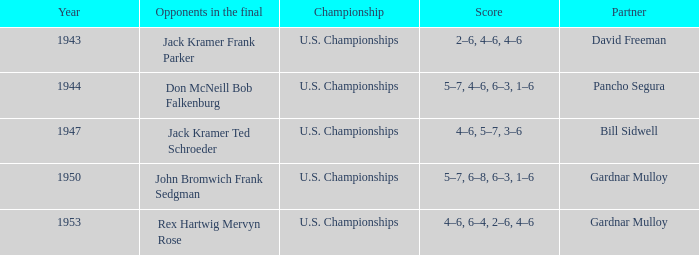Can you parse all the data within this table? {'header': ['Year', 'Opponents in the final', 'Championship', 'Score', 'Partner'], 'rows': [['1943', 'Jack Kramer Frank Parker', 'U.S. Championships', '2–6, 4–6, 4–6', 'David Freeman'], ['1944', 'Don McNeill Bob Falkenburg', 'U.S. Championships', '5–7, 4–6, 6–3, 1–6', 'Pancho Segura'], ['1947', 'Jack Kramer Ted Schroeder', 'U.S. Championships', '4–6, 5–7, 3–6', 'Bill Sidwell'], ['1950', 'John Bromwich Frank Sedgman', 'U.S. Championships', '5–7, 6–8, 6–3, 1–6', 'Gardnar Mulloy'], ['1953', 'Rex Hartwig Mervyn Rose', 'U.S. Championships', '4–6, 6–4, 2–6, 4–6', 'Gardnar Mulloy']]} Which Score has Opponents in the final of john bromwich frank sedgman? 5–7, 6–8, 6–3, 1–6. 